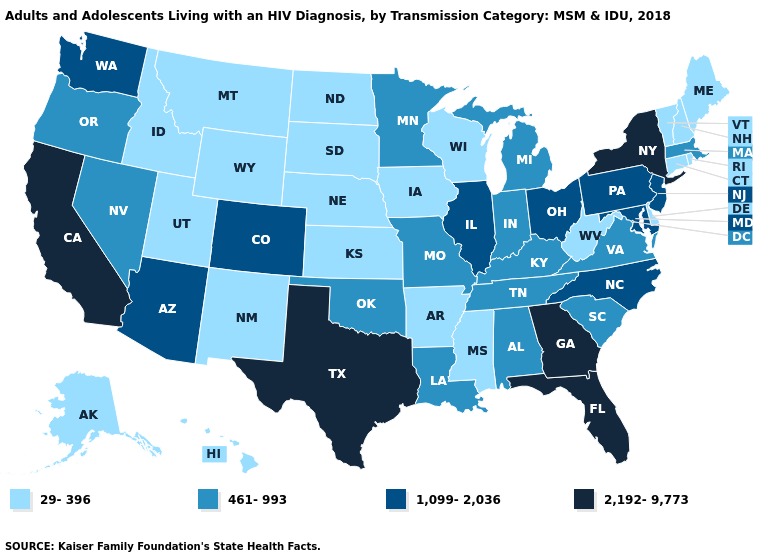What is the value of Illinois?
Give a very brief answer. 1,099-2,036. Does the first symbol in the legend represent the smallest category?
Quick response, please. Yes. Among the states that border Connecticut , does New York have the highest value?
Concise answer only. Yes. Does Rhode Island have the highest value in the USA?
Quick response, please. No. What is the highest value in the MidWest ?
Short answer required. 1,099-2,036. What is the value of West Virginia?
Concise answer only. 29-396. Is the legend a continuous bar?
Give a very brief answer. No. Among the states that border Colorado , which have the highest value?
Short answer required. Arizona. Name the states that have a value in the range 2,192-9,773?
Short answer required. California, Florida, Georgia, New York, Texas. What is the value of New Jersey?
Give a very brief answer. 1,099-2,036. How many symbols are there in the legend?
Keep it brief. 4. What is the highest value in states that border Nebraska?
Write a very short answer. 1,099-2,036. Name the states that have a value in the range 29-396?
Give a very brief answer. Alaska, Arkansas, Connecticut, Delaware, Hawaii, Idaho, Iowa, Kansas, Maine, Mississippi, Montana, Nebraska, New Hampshire, New Mexico, North Dakota, Rhode Island, South Dakota, Utah, Vermont, West Virginia, Wisconsin, Wyoming. Which states have the lowest value in the USA?
Quick response, please. Alaska, Arkansas, Connecticut, Delaware, Hawaii, Idaho, Iowa, Kansas, Maine, Mississippi, Montana, Nebraska, New Hampshire, New Mexico, North Dakota, Rhode Island, South Dakota, Utah, Vermont, West Virginia, Wisconsin, Wyoming. Does Arizona have the highest value in the West?
Concise answer only. No. 